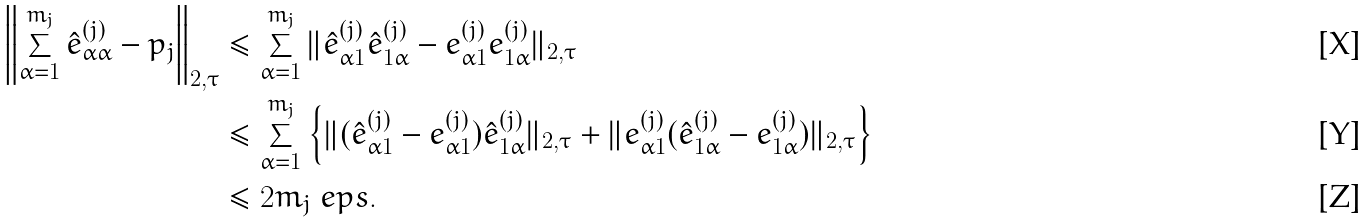<formula> <loc_0><loc_0><loc_500><loc_500>\left \| \sum _ { \alpha = 1 } ^ { m _ { j } } \hat { e } _ { \alpha \alpha } ^ { ( j ) } - p _ { j } \right \| _ { 2 , \tau } & \leq \sum _ { \alpha = 1 } ^ { m _ { j } } \| \hat { e } _ { \alpha 1 } ^ { ( j ) } \hat { e } _ { 1 \alpha } ^ { ( j ) } - e _ { \alpha 1 } ^ { ( j ) } e _ { 1 \alpha } ^ { ( j ) } \| _ { 2 , \tau } \\ & \leq \sum _ { \alpha = 1 } ^ { m _ { j } } \left \{ \| ( \hat { e } _ { \alpha 1 } ^ { ( j ) } - e _ { \alpha 1 } ^ { ( j ) } ) \hat { e } _ { 1 \alpha } ^ { ( j ) } \| _ { 2 , \tau } + \| e _ { \alpha 1 } ^ { ( j ) } ( \hat { e } _ { 1 \alpha } ^ { ( j ) } - e _ { 1 \alpha } ^ { ( j ) } ) \| _ { 2 , \tau } \right \} \\ & \leq 2 m _ { j } \ e p s .</formula> 